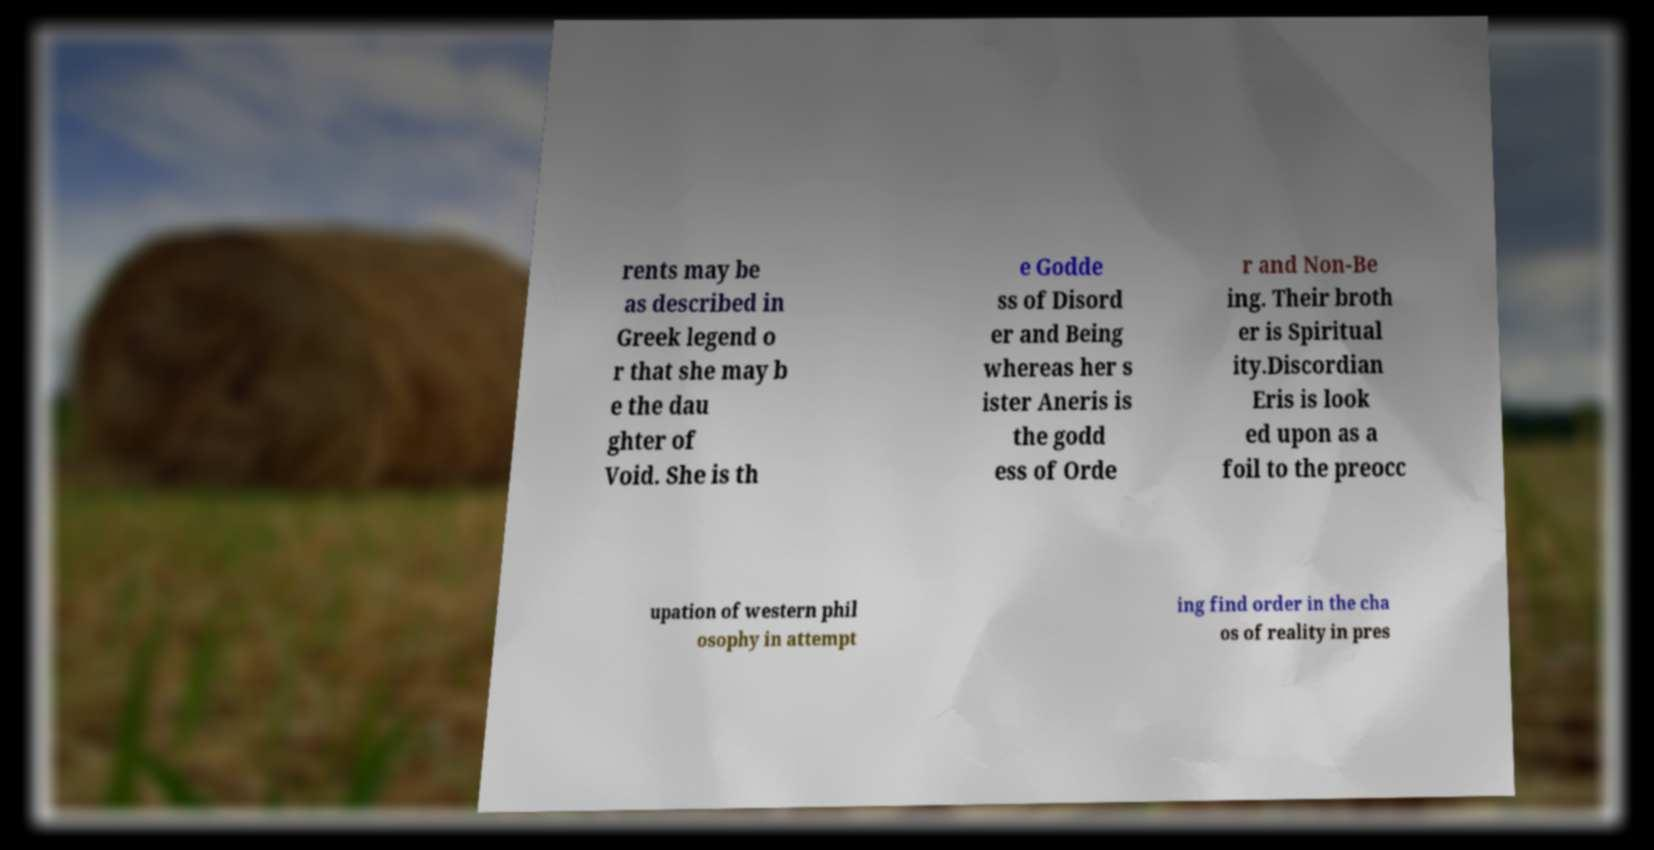What messages or text are displayed in this image? I need them in a readable, typed format. rents may be as described in Greek legend o r that she may b e the dau ghter of Void. She is th e Godde ss of Disord er and Being whereas her s ister Aneris is the godd ess of Orde r and Non-Be ing. Their broth er is Spiritual ity.Discordian Eris is look ed upon as a foil to the preocc upation of western phil osophy in attempt ing find order in the cha os of reality in pres 